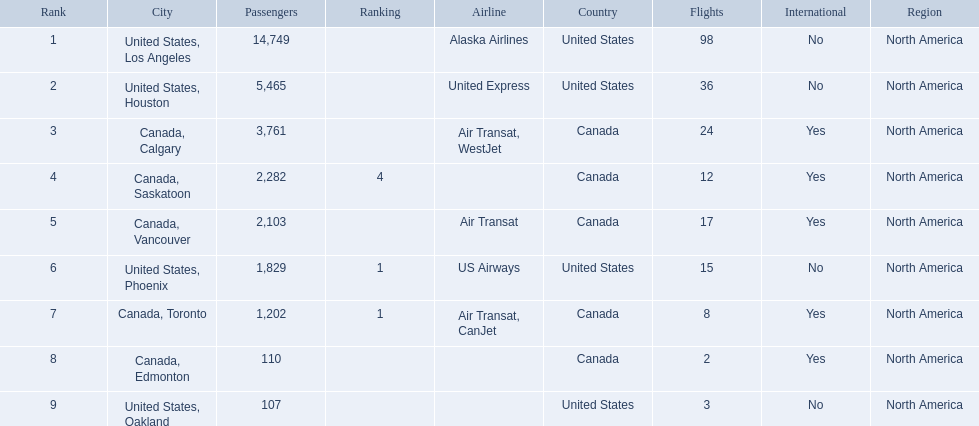What numbers are in the passengers column? 14,749, 5,465, 3,761, 2,282, 2,103, 1,829, 1,202, 110, 107. Which number is the lowest number in the passengers column? 107. What city is associated with this number? United States, Oakland. Can you give me this table as a dict? {'header': ['Rank', 'City', 'Passengers', 'Ranking', 'Airline', 'Country', 'Flights', 'International', 'Region'], 'rows': [['1', 'United States, Los Angeles', '14,749', '', 'Alaska Airlines', 'United States', '98', 'No', 'North America'], ['2', 'United States, Houston', '5,465', '', 'United Express', 'United States', '36', 'No', 'North America'], ['3', 'Canada, Calgary', '3,761', '', 'Air Transat, WestJet', 'Canada', '24', 'Yes', 'North America'], ['4', 'Canada, Saskatoon', '2,282', '4', '', 'Canada', '12', 'Yes', 'North America'], ['5', 'Canada, Vancouver', '2,103', '', 'Air Transat', 'Canada', '17', 'Yes', 'North America'], ['6', 'United States, Phoenix', '1,829', '1', 'US Airways', 'United States', '15', 'No', 'North America'], ['7', 'Canada, Toronto', '1,202', '1', 'Air Transat, CanJet', 'Canada', '8', 'Yes', 'North America'], ['8', 'Canada, Edmonton', '110', '', '', 'Canada', '2', 'Yes', 'North America'], ['9', 'United States, Oakland', '107', '', '', 'United States', '3', 'No', 'North America']]} 